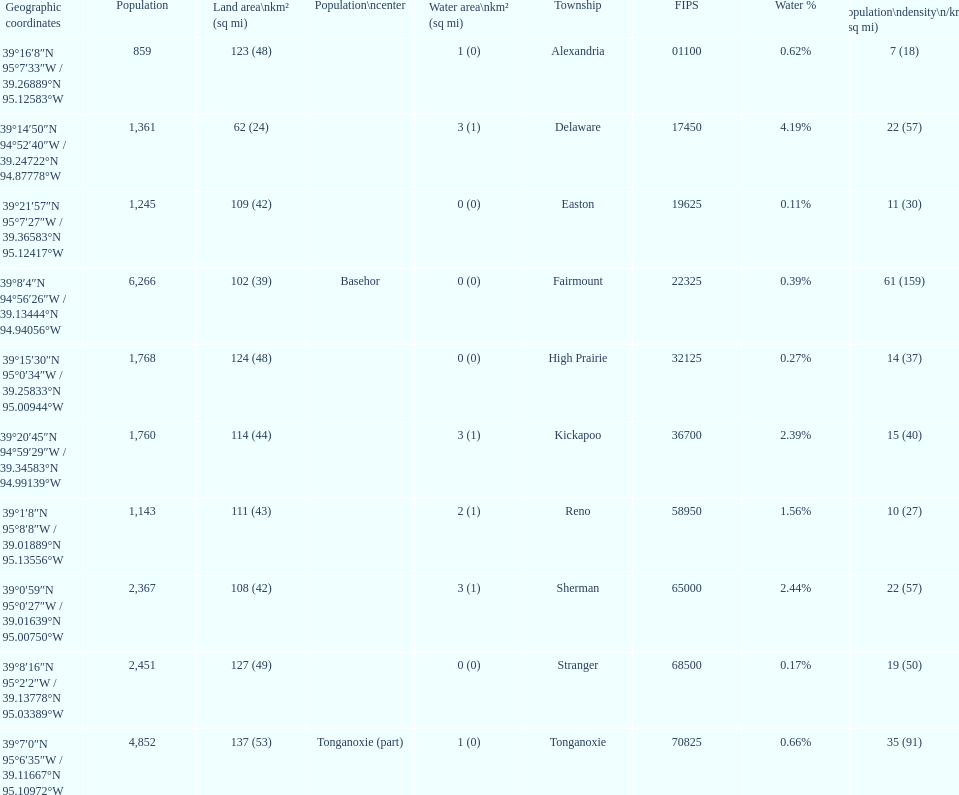How many townships are in leavenworth county? 10. 